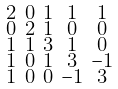Convert formula to latex. <formula><loc_0><loc_0><loc_500><loc_500>\begin{smallmatrix} 2 & 0 & 1 & 1 & 1 \\ 0 & 2 & 1 & 0 & 0 \\ 1 & 1 & 3 & 1 & 0 \\ 1 & 0 & 1 & 3 & - 1 \\ 1 & 0 & 0 & - 1 & 3 \end{smallmatrix}</formula> 